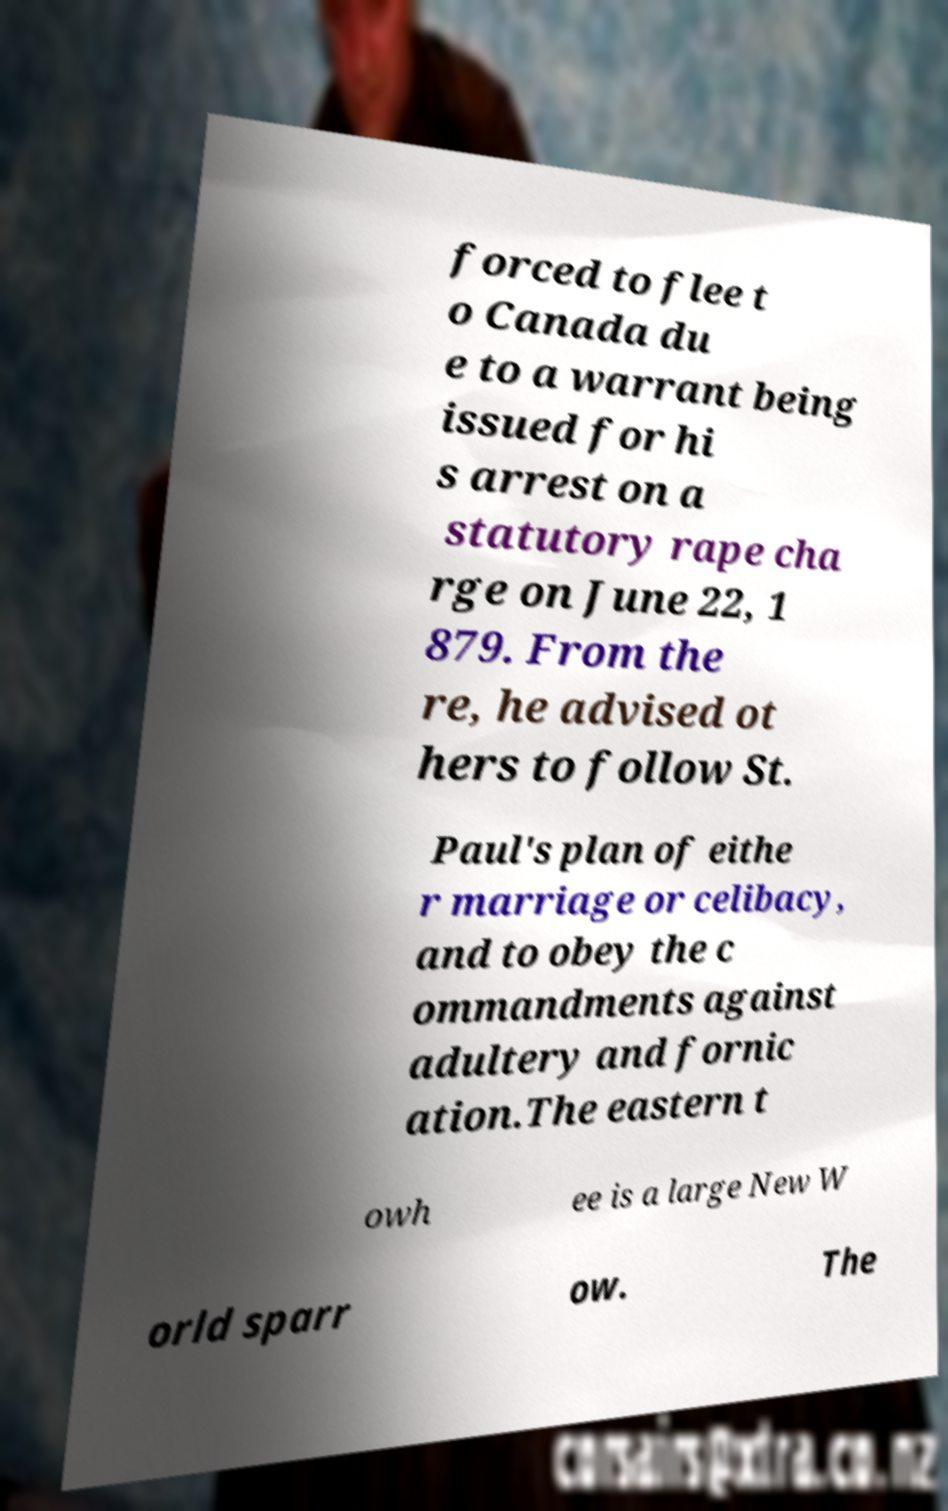Can you accurately transcribe the text from the provided image for me? forced to flee t o Canada du e to a warrant being issued for hi s arrest on a statutory rape cha rge on June 22, 1 879. From the re, he advised ot hers to follow St. Paul's plan of eithe r marriage or celibacy, and to obey the c ommandments against adultery and fornic ation.The eastern t owh ee is a large New W orld sparr ow. The 